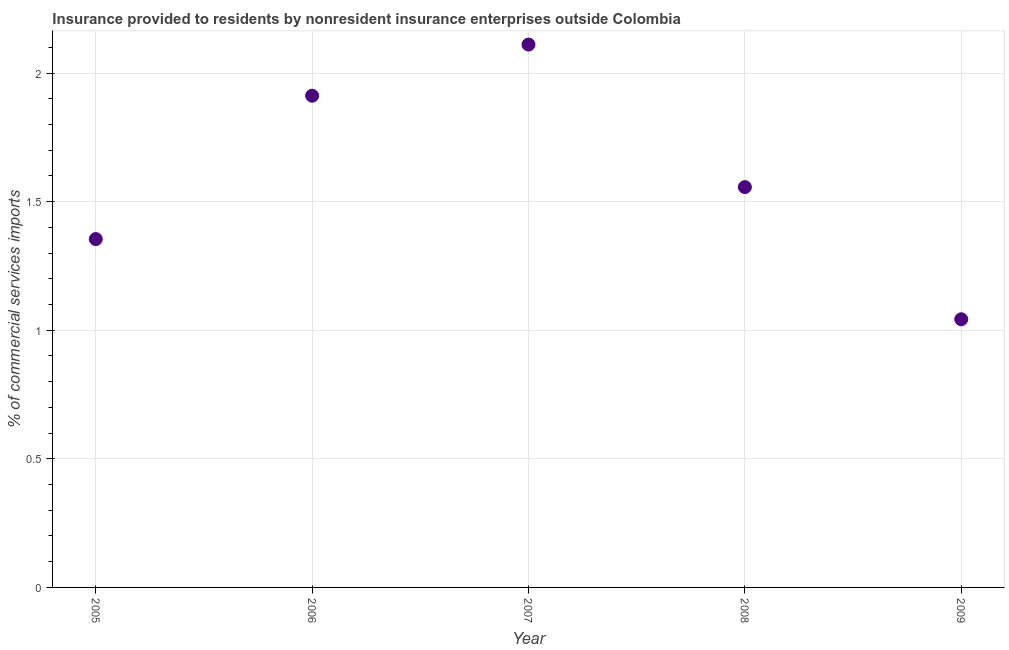What is the insurance provided by non-residents in 2006?
Offer a terse response. 1.91. Across all years, what is the maximum insurance provided by non-residents?
Provide a succinct answer. 2.11. Across all years, what is the minimum insurance provided by non-residents?
Ensure brevity in your answer.  1.04. In which year was the insurance provided by non-residents minimum?
Make the answer very short. 2009. What is the sum of the insurance provided by non-residents?
Your response must be concise. 7.98. What is the difference between the insurance provided by non-residents in 2006 and 2009?
Give a very brief answer. 0.87. What is the average insurance provided by non-residents per year?
Make the answer very short. 1.6. What is the median insurance provided by non-residents?
Offer a terse response. 1.56. In how many years, is the insurance provided by non-residents greater than 1.3 %?
Give a very brief answer. 4. Do a majority of the years between 2007 and 2005 (inclusive) have insurance provided by non-residents greater than 0.7 %?
Make the answer very short. No. What is the ratio of the insurance provided by non-residents in 2005 to that in 2007?
Offer a very short reply. 0.64. What is the difference between the highest and the second highest insurance provided by non-residents?
Make the answer very short. 0.2. Is the sum of the insurance provided by non-residents in 2006 and 2009 greater than the maximum insurance provided by non-residents across all years?
Your response must be concise. Yes. What is the difference between the highest and the lowest insurance provided by non-residents?
Provide a succinct answer. 1.07. In how many years, is the insurance provided by non-residents greater than the average insurance provided by non-residents taken over all years?
Provide a succinct answer. 2. How many dotlines are there?
Offer a very short reply. 1. What is the difference between two consecutive major ticks on the Y-axis?
Your answer should be compact. 0.5. Are the values on the major ticks of Y-axis written in scientific E-notation?
Offer a terse response. No. What is the title of the graph?
Provide a short and direct response. Insurance provided to residents by nonresident insurance enterprises outside Colombia. What is the label or title of the X-axis?
Keep it short and to the point. Year. What is the label or title of the Y-axis?
Your answer should be very brief. % of commercial services imports. What is the % of commercial services imports in 2005?
Your answer should be compact. 1.35. What is the % of commercial services imports in 2006?
Offer a very short reply. 1.91. What is the % of commercial services imports in 2007?
Offer a terse response. 2.11. What is the % of commercial services imports in 2008?
Your response must be concise. 1.56. What is the % of commercial services imports in 2009?
Provide a succinct answer. 1.04. What is the difference between the % of commercial services imports in 2005 and 2006?
Offer a terse response. -0.56. What is the difference between the % of commercial services imports in 2005 and 2007?
Your answer should be compact. -0.76. What is the difference between the % of commercial services imports in 2005 and 2008?
Ensure brevity in your answer.  -0.2. What is the difference between the % of commercial services imports in 2005 and 2009?
Give a very brief answer. 0.31. What is the difference between the % of commercial services imports in 2006 and 2007?
Offer a terse response. -0.2. What is the difference between the % of commercial services imports in 2006 and 2008?
Offer a very short reply. 0.36. What is the difference between the % of commercial services imports in 2006 and 2009?
Offer a very short reply. 0.87. What is the difference between the % of commercial services imports in 2007 and 2008?
Give a very brief answer. 0.55. What is the difference between the % of commercial services imports in 2007 and 2009?
Offer a very short reply. 1.07. What is the difference between the % of commercial services imports in 2008 and 2009?
Make the answer very short. 0.51. What is the ratio of the % of commercial services imports in 2005 to that in 2006?
Keep it short and to the point. 0.71. What is the ratio of the % of commercial services imports in 2005 to that in 2007?
Your response must be concise. 0.64. What is the ratio of the % of commercial services imports in 2005 to that in 2008?
Your answer should be compact. 0.87. What is the ratio of the % of commercial services imports in 2005 to that in 2009?
Ensure brevity in your answer.  1.3. What is the ratio of the % of commercial services imports in 2006 to that in 2007?
Ensure brevity in your answer.  0.91. What is the ratio of the % of commercial services imports in 2006 to that in 2008?
Provide a succinct answer. 1.23. What is the ratio of the % of commercial services imports in 2006 to that in 2009?
Give a very brief answer. 1.83. What is the ratio of the % of commercial services imports in 2007 to that in 2008?
Make the answer very short. 1.36. What is the ratio of the % of commercial services imports in 2007 to that in 2009?
Your answer should be very brief. 2.02. What is the ratio of the % of commercial services imports in 2008 to that in 2009?
Offer a terse response. 1.49. 